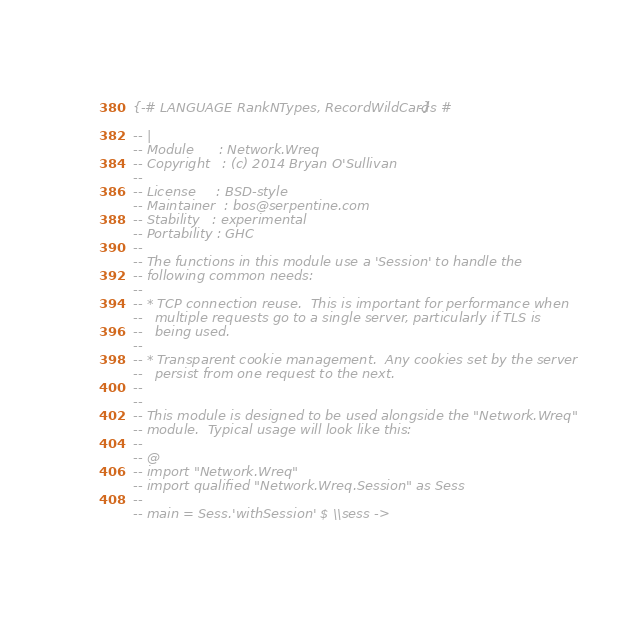Convert code to text. <code><loc_0><loc_0><loc_500><loc_500><_Haskell_>{-# LANGUAGE RankNTypes, RecordWildCards #-}

-- |
-- Module      : Network.Wreq
-- Copyright   : (c) 2014 Bryan O'Sullivan
--
-- License     : BSD-style
-- Maintainer  : bos@serpentine.com
-- Stability   : experimental
-- Portability : GHC
--
-- The functions in this module use a 'Session' to handle the
-- following common needs:
--
-- * TCP connection reuse.  This is important for performance when
--   multiple requests go to a single server, particularly if TLS is
--   being used.
--
-- * Transparent cookie management.  Any cookies set by the server
--   persist from one request to the next.
--
--
-- This module is designed to be used alongside the "Network.Wreq"
-- module.  Typical usage will look like this:
--
-- @
-- import "Network.Wreq"
-- import qualified "Network.Wreq.Session" as Sess
--
-- main = Sess.'withSession' $ \\sess -></code> 